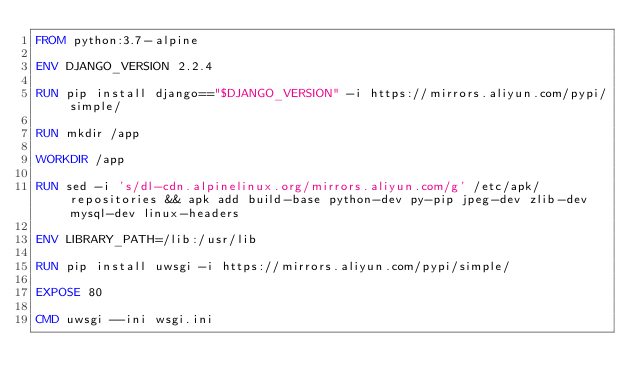<code> <loc_0><loc_0><loc_500><loc_500><_Dockerfile_>FROM python:3.7-alpine

ENV DJANGO_VERSION 2.2.4

RUN pip install django=="$DJANGO_VERSION" -i https://mirrors.aliyun.com/pypi/simple/

RUN mkdir /app

WORKDIR /app

RUN sed -i 's/dl-cdn.alpinelinux.org/mirrors.aliyun.com/g' /etc/apk/repositories && apk add build-base python-dev py-pip jpeg-dev zlib-dev mysql-dev linux-headers

ENV LIBRARY_PATH=/lib:/usr/lib

RUN pip install uwsgi -i https://mirrors.aliyun.com/pypi/simple/

EXPOSE 80

CMD uwsgi --ini wsgi.ini
</code> 